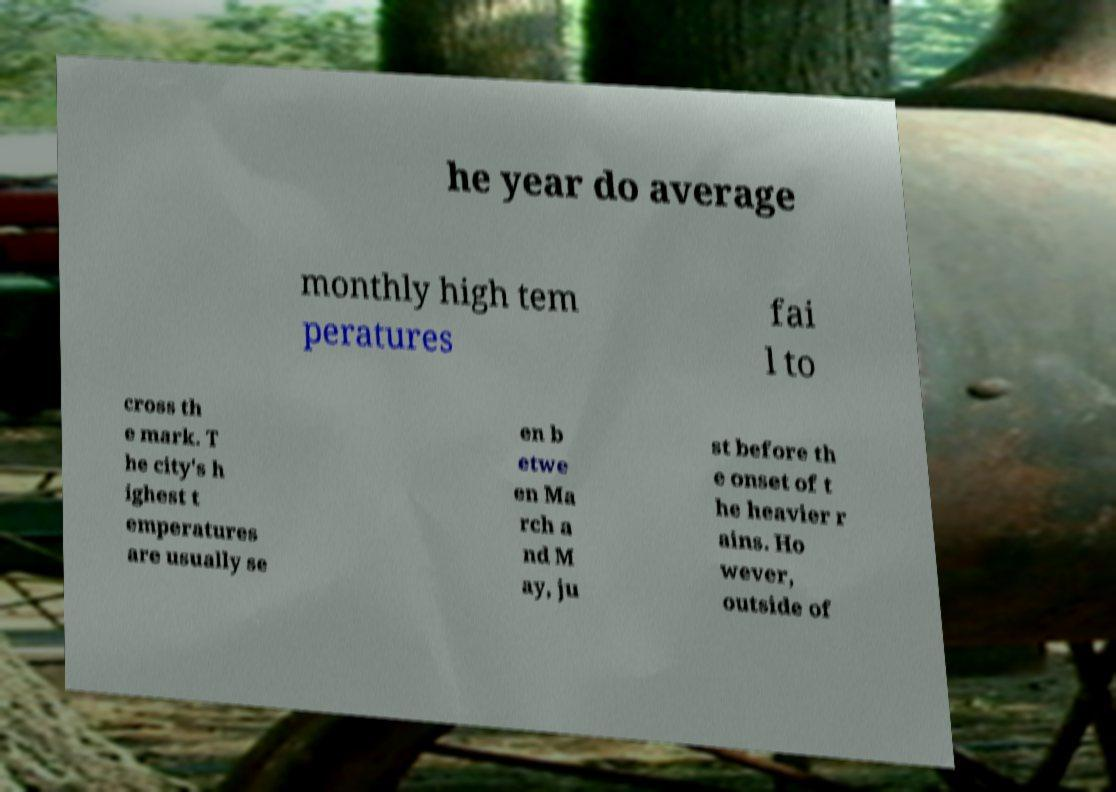Please read and relay the text visible in this image. What does it say? he year do average monthly high tem peratures fai l to cross th e mark. T he city's h ighest t emperatures are usually se en b etwe en Ma rch a nd M ay, ju st before th e onset of t he heavier r ains. Ho wever, outside of 